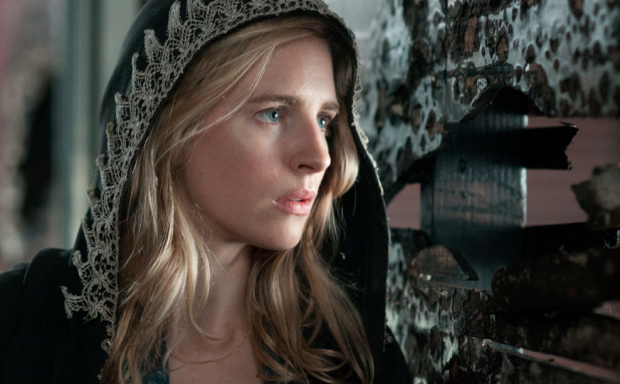Tell a short story inspired by this image. In a city forgotten by time, Elara walked the desolate streets cloaked in her ancestral hood, embroidered with the intricate lace of her forebears. The crumbling posters that adorned the walls whispered secrets of a bygone era when her family had held a great but hidden power. Tonight, the air was thick with anticipation. Elara had discovered a clue — a faded map embedded in the layers of paper on the wall. As she traced the path on the map, her heart pounded with the weight of destiny. The final piece of the puzzle was near. All she needed to do was follow the clues and trust in the legacy her cloak symbolized. 